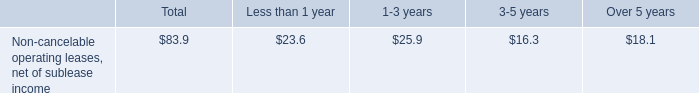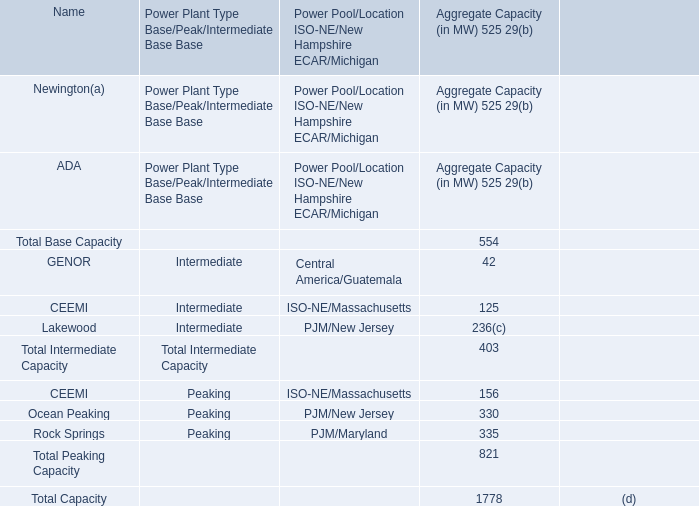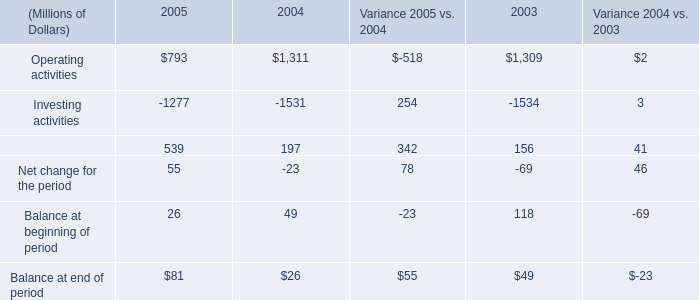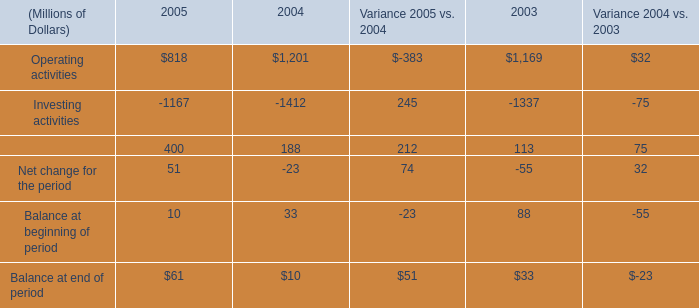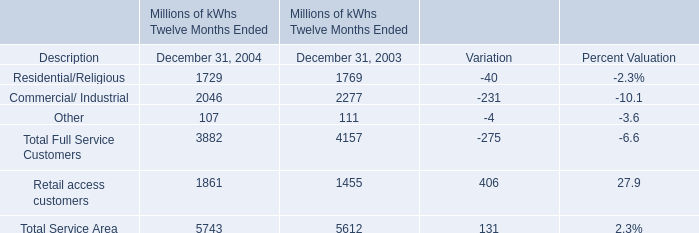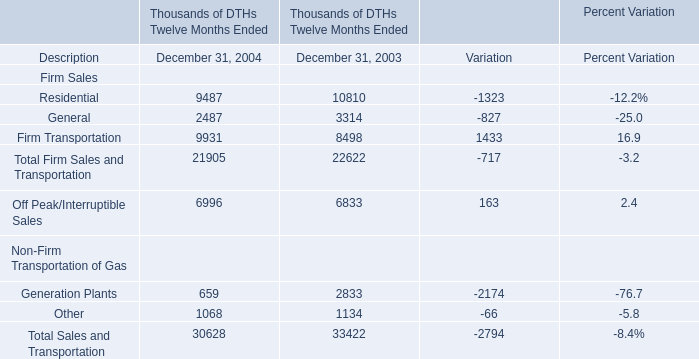Does the value of Residential in 2004 greater than that in 2003? 
Answer: No. 